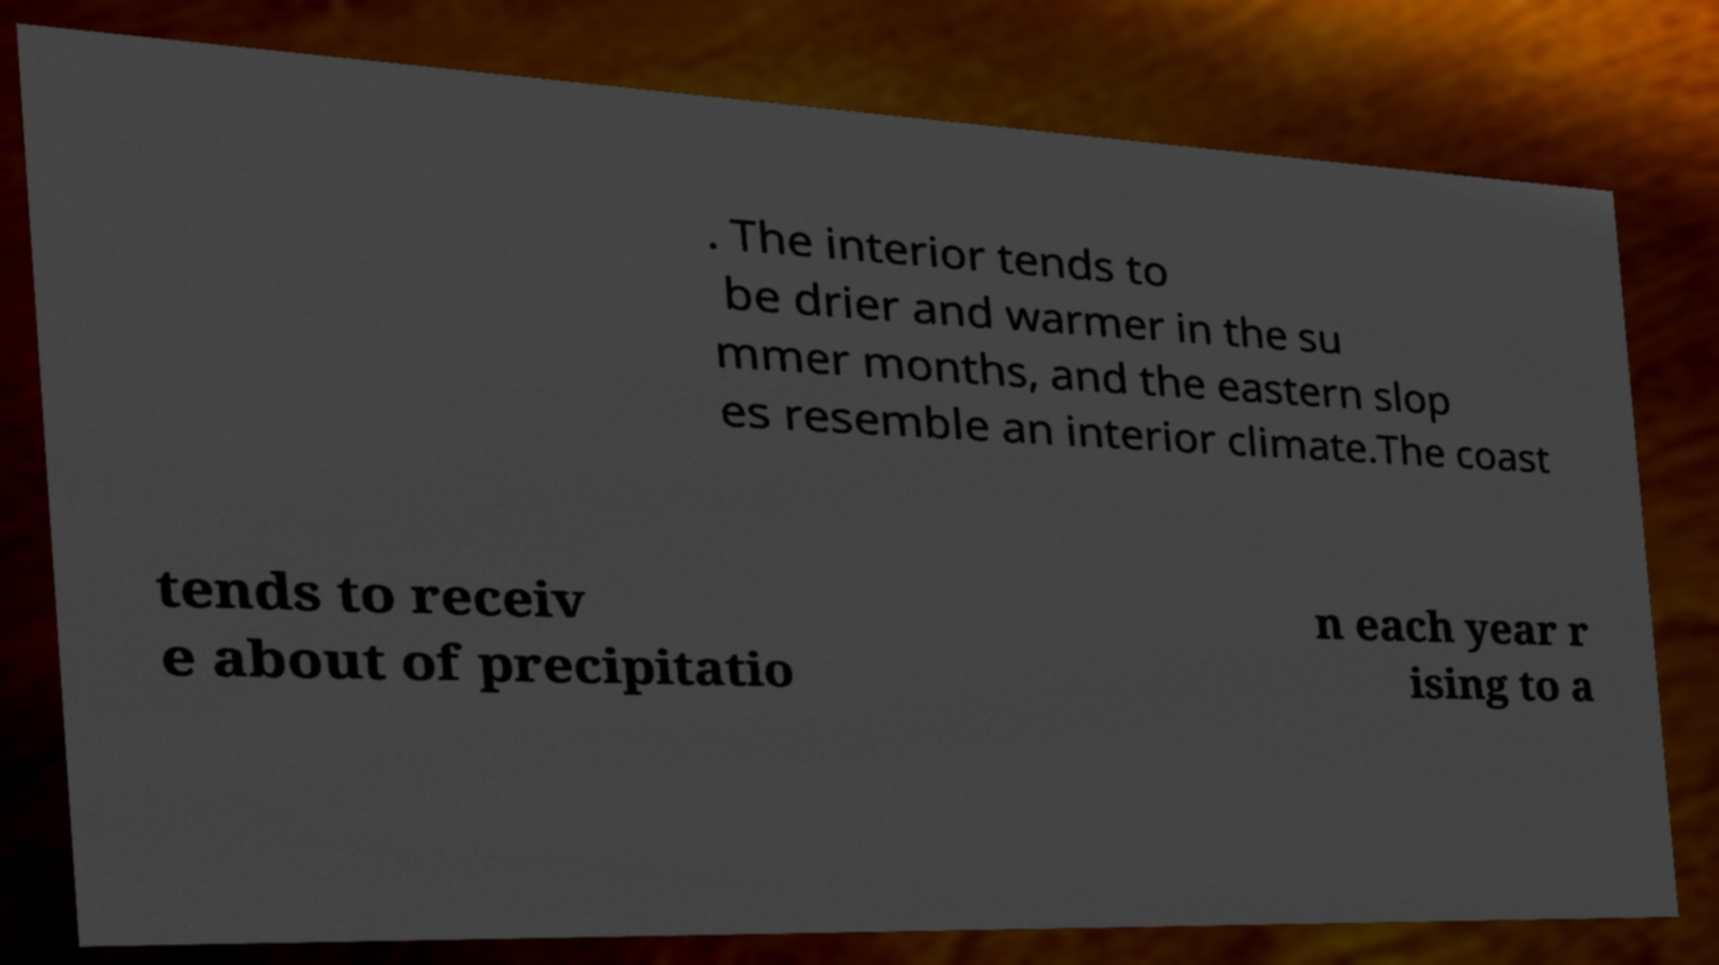Can you read and provide the text displayed in the image?This photo seems to have some interesting text. Can you extract and type it out for me? . The interior tends to be drier and warmer in the su mmer months, and the eastern slop es resemble an interior climate.The coast tends to receiv e about of precipitatio n each year r ising to a 